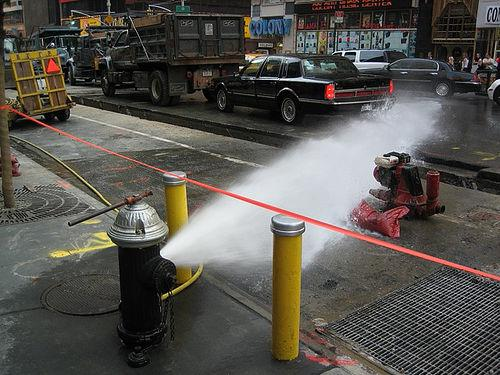Question: what direction is the orange arrow on the left side of the photo pointing?
Choices:
A. Down.
B. West.
C. Upward.
D. North.
Answer with the letter. Answer: C Question: where are the cars located?
Choices:
A. Parking garage.
B. In the parking lot.
C. On the road.
D. Street.
Answer with the letter. Answer: D Question: how many fire hydrants are visible in the photo?
Choices:
A. Two.
B. Three.
C. One.
D. Four.
Answer with the letter. Answer: C 